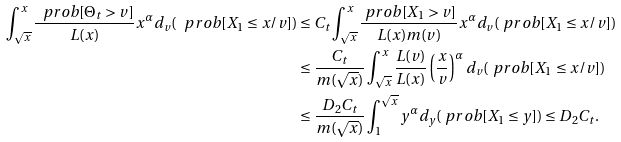<formula> <loc_0><loc_0><loc_500><loc_500>\int _ { \sqrt { x } } ^ { x } \frac { \ p r o b [ \Theta _ { t } > v ] } { L ( x ) } x ^ { \alpha } d _ { v } ( \ p r o b [ X _ { 1 } \leq x / v ] ) & \leq C _ { t } \int _ { \sqrt { x } } ^ { x } \frac { \ p r o b [ X _ { 1 } > v ] } { L ( x ) m ( v ) } x ^ { \alpha } d _ { v } ( \ p r o b [ X _ { 1 } \leq x / v ] ) \\ & \leq \frac { C _ { t } } { m ( \sqrt { x } ) } \int _ { \sqrt { x } } ^ { x } \frac { L ( v ) } { L ( x ) } \left ( \frac { x } { v } \right ) ^ { \alpha } d _ { v } ( \ p r o b [ X _ { 1 } \leq x / v ] ) \\ & \leq \frac { D _ { 2 } C _ { t } } { m ( \sqrt { x } ) } \int _ { 1 } ^ { \sqrt { x } } y ^ { \alpha } d _ { y } ( \ p r o b [ X _ { 1 } \leq y ] ) \leq D _ { 2 } C _ { t } .</formula> 